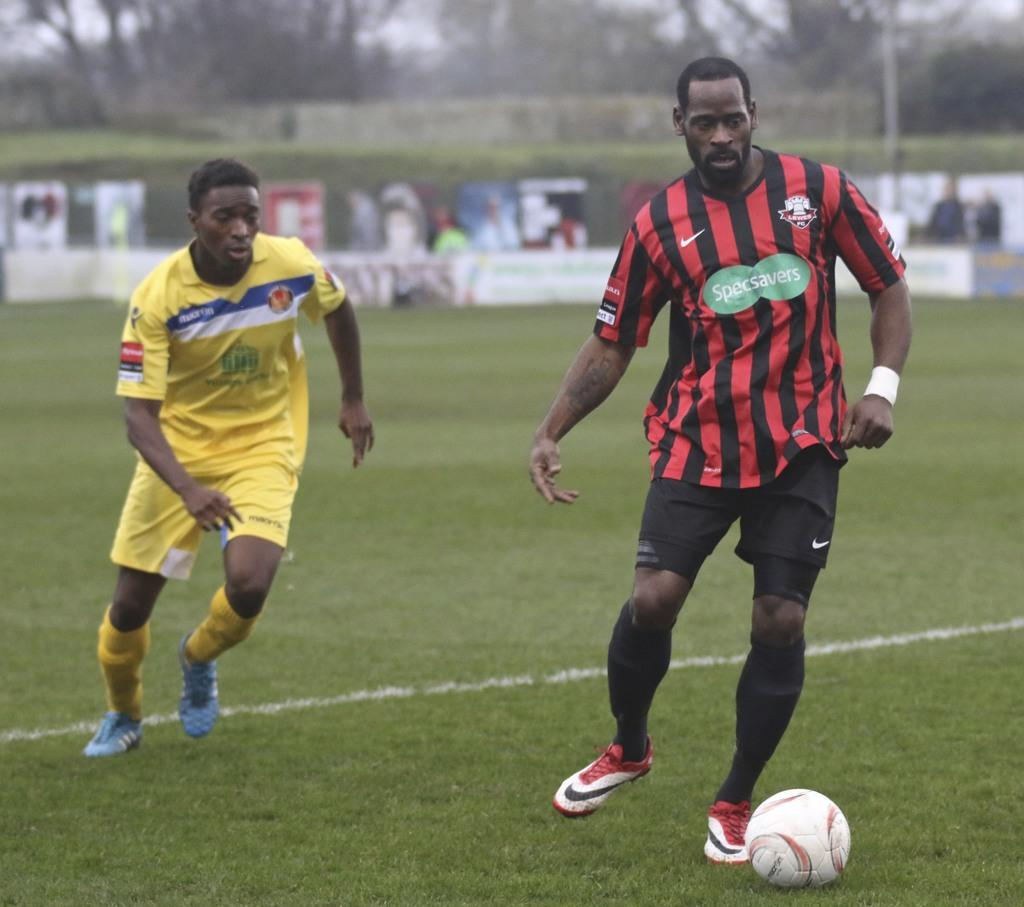<image>
Share a concise interpretation of the image provided. A soccer player with a sign on his jersey that says "Specsavers" 